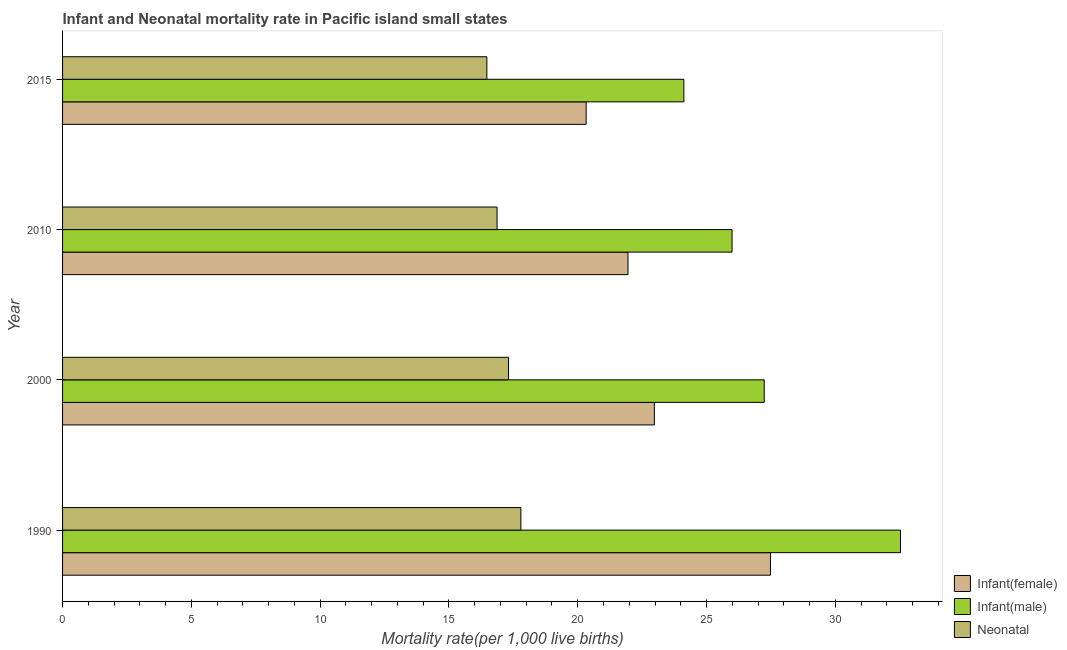How many groups of bars are there?
Provide a succinct answer. 4. How many bars are there on the 1st tick from the top?
Ensure brevity in your answer.  3. How many bars are there on the 3rd tick from the bottom?
Make the answer very short. 3. What is the label of the 2nd group of bars from the top?
Keep it short and to the point. 2010. What is the infant mortality rate(male) in 2015?
Your answer should be very brief. 24.12. Across all years, what is the maximum neonatal mortality rate?
Provide a succinct answer. 17.79. Across all years, what is the minimum infant mortality rate(male)?
Make the answer very short. 24.12. In which year was the infant mortality rate(male) minimum?
Your response must be concise. 2015. What is the total neonatal mortality rate in the graph?
Your answer should be very brief. 68.45. What is the difference between the neonatal mortality rate in 2010 and that in 2015?
Ensure brevity in your answer.  0.4. What is the difference between the infant mortality rate(female) in 1990 and the neonatal mortality rate in 2010?
Keep it short and to the point. 10.61. What is the average infant mortality rate(male) per year?
Provide a short and direct response. 27.47. In the year 1990, what is the difference between the neonatal mortality rate and infant mortality rate(male)?
Your answer should be very brief. -14.74. Is the neonatal mortality rate in 1990 less than that in 2000?
Your response must be concise. No. What is the difference between the highest and the second highest neonatal mortality rate?
Make the answer very short. 0.48. What is the difference between the highest and the lowest infant mortality rate(female)?
Make the answer very short. 7.16. What does the 2nd bar from the top in 1990 represents?
Provide a succinct answer. Infant(male). What does the 2nd bar from the bottom in 2010 represents?
Provide a short and direct response. Infant(male). How many bars are there?
Your response must be concise. 12. How many years are there in the graph?
Offer a terse response. 4. What is the difference between two consecutive major ticks on the X-axis?
Provide a succinct answer. 5. Are the values on the major ticks of X-axis written in scientific E-notation?
Ensure brevity in your answer.  No. How many legend labels are there?
Provide a succinct answer. 3. What is the title of the graph?
Give a very brief answer. Infant and Neonatal mortality rate in Pacific island small states. Does "Domestic" appear as one of the legend labels in the graph?
Keep it short and to the point. No. What is the label or title of the X-axis?
Offer a very short reply. Mortality rate(per 1,0 live births). What is the Mortality rate(per 1,000 live births) in Infant(female) in 1990?
Give a very brief answer. 27.48. What is the Mortality rate(per 1,000 live births) of Infant(male) in 1990?
Offer a very short reply. 32.53. What is the Mortality rate(per 1,000 live births) in Neonatal  in 1990?
Make the answer very short. 17.79. What is the Mortality rate(per 1,000 live births) in Infant(female) in 2000?
Offer a terse response. 22.97. What is the Mortality rate(per 1,000 live births) of Infant(male) in 2000?
Your answer should be compact. 27.24. What is the Mortality rate(per 1,000 live births) of Neonatal  in 2000?
Keep it short and to the point. 17.31. What is the Mortality rate(per 1,000 live births) in Infant(female) in 2010?
Your response must be concise. 21.95. What is the Mortality rate(per 1,000 live births) of Infant(male) in 2010?
Offer a very short reply. 25.99. What is the Mortality rate(per 1,000 live births) of Neonatal  in 2010?
Give a very brief answer. 16.87. What is the Mortality rate(per 1,000 live births) in Infant(female) in 2015?
Keep it short and to the point. 20.33. What is the Mortality rate(per 1,000 live births) in Infant(male) in 2015?
Give a very brief answer. 24.12. What is the Mortality rate(per 1,000 live births) in Neonatal  in 2015?
Ensure brevity in your answer.  16.47. Across all years, what is the maximum Mortality rate(per 1,000 live births) in Infant(female)?
Ensure brevity in your answer.  27.48. Across all years, what is the maximum Mortality rate(per 1,000 live births) of Infant(male)?
Give a very brief answer. 32.53. Across all years, what is the maximum Mortality rate(per 1,000 live births) of Neonatal ?
Your answer should be very brief. 17.79. Across all years, what is the minimum Mortality rate(per 1,000 live births) in Infant(female)?
Make the answer very short. 20.33. Across all years, what is the minimum Mortality rate(per 1,000 live births) of Infant(male)?
Provide a short and direct response. 24.12. Across all years, what is the minimum Mortality rate(per 1,000 live births) of Neonatal ?
Provide a succinct answer. 16.47. What is the total Mortality rate(per 1,000 live births) of Infant(female) in the graph?
Your answer should be compact. 92.73. What is the total Mortality rate(per 1,000 live births) of Infant(male) in the graph?
Give a very brief answer. 109.88. What is the total Mortality rate(per 1,000 live births) in Neonatal  in the graph?
Make the answer very short. 68.45. What is the difference between the Mortality rate(per 1,000 live births) in Infant(female) in 1990 and that in 2000?
Offer a very short reply. 4.51. What is the difference between the Mortality rate(per 1,000 live births) of Infant(male) in 1990 and that in 2000?
Provide a short and direct response. 5.29. What is the difference between the Mortality rate(per 1,000 live births) in Neonatal  in 1990 and that in 2000?
Your response must be concise. 0.48. What is the difference between the Mortality rate(per 1,000 live births) of Infant(female) in 1990 and that in 2010?
Your answer should be compact. 5.53. What is the difference between the Mortality rate(per 1,000 live births) of Infant(male) in 1990 and that in 2010?
Give a very brief answer. 6.54. What is the difference between the Mortality rate(per 1,000 live births) of Neonatal  in 1990 and that in 2010?
Provide a short and direct response. 0.92. What is the difference between the Mortality rate(per 1,000 live births) of Infant(female) in 1990 and that in 2015?
Your answer should be compact. 7.16. What is the difference between the Mortality rate(per 1,000 live births) in Infant(male) in 1990 and that in 2015?
Provide a succinct answer. 8.41. What is the difference between the Mortality rate(per 1,000 live births) of Neonatal  in 1990 and that in 2015?
Offer a very short reply. 1.32. What is the difference between the Mortality rate(per 1,000 live births) of Infant(female) in 2000 and that in 2010?
Provide a short and direct response. 1.02. What is the difference between the Mortality rate(per 1,000 live births) in Infant(male) in 2000 and that in 2010?
Provide a short and direct response. 1.25. What is the difference between the Mortality rate(per 1,000 live births) of Neonatal  in 2000 and that in 2010?
Your answer should be very brief. 0.45. What is the difference between the Mortality rate(per 1,000 live births) of Infant(female) in 2000 and that in 2015?
Your answer should be very brief. 2.65. What is the difference between the Mortality rate(per 1,000 live births) in Infant(male) in 2000 and that in 2015?
Your response must be concise. 3.12. What is the difference between the Mortality rate(per 1,000 live births) in Neonatal  in 2000 and that in 2015?
Give a very brief answer. 0.84. What is the difference between the Mortality rate(per 1,000 live births) of Infant(female) in 2010 and that in 2015?
Make the answer very short. 1.62. What is the difference between the Mortality rate(per 1,000 live births) of Infant(male) in 2010 and that in 2015?
Ensure brevity in your answer.  1.87. What is the difference between the Mortality rate(per 1,000 live births) in Neonatal  in 2010 and that in 2015?
Provide a succinct answer. 0.4. What is the difference between the Mortality rate(per 1,000 live births) in Infant(female) in 1990 and the Mortality rate(per 1,000 live births) in Infant(male) in 2000?
Give a very brief answer. 0.24. What is the difference between the Mortality rate(per 1,000 live births) of Infant(female) in 1990 and the Mortality rate(per 1,000 live births) of Neonatal  in 2000?
Your answer should be very brief. 10.17. What is the difference between the Mortality rate(per 1,000 live births) in Infant(male) in 1990 and the Mortality rate(per 1,000 live births) in Neonatal  in 2000?
Ensure brevity in your answer.  15.22. What is the difference between the Mortality rate(per 1,000 live births) of Infant(female) in 1990 and the Mortality rate(per 1,000 live births) of Infant(male) in 2010?
Offer a very short reply. 1.49. What is the difference between the Mortality rate(per 1,000 live births) in Infant(female) in 1990 and the Mortality rate(per 1,000 live births) in Neonatal  in 2010?
Make the answer very short. 10.61. What is the difference between the Mortality rate(per 1,000 live births) of Infant(male) in 1990 and the Mortality rate(per 1,000 live births) of Neonatal  in 2010?
Offer a very short reply. 15.66. What is the difference between the Mortality rate(per 1,000 live births) of Infant(female) in 1990 and the Mortality rate(per 1,000 live births) of Infant(male) in 2015?
Your answer should be very brief. 3.36. What is the difference between the Mortality rate(per 1,000 live births) of Infant(female) in 1990 and the Mortality rate(per 1,000 live births) of Neonatal  in 2015?
Make the answer very short. 11.01. What is the difference between the Mortality rate(per 1,000 live births) of Infant(male) in 1990 and the Mortality rate(per 1,000 live births) of Neonatal  in 2015?
Offer a terse response. 16.06. What is the difference between the Mortality rate(per 1,000 live births) of Infant(female) in 2000 and the Mortality rate(per 1,000 live births) of Infant(male) in 2010?
Your answer should be very brief. -3.02. What is the difference between the Mortality rate(per 1,000 live births) in Infant(female) in 2000 and the Mortality rate(per 1,000 live births) in Neonatal  in 2010?
Make the answer very short. 6.11. What is the difference between the Mortality rate(per 1,000 live births) in Infant(male) in 2000 and the Mortality rate(per 1,000 live births) in Neonatal  in 2010?
Ensure brevity in your answer.  10.37. What is the difference between the Mortality rate(per 1,000 live births) in Infant(female) in 2000 and the Mortality rate(per 1,000 live births) in Infant(male) in 2015?
Keep it short and to the point. -1.15. What is the difference between the Mortality rate(per 1,000 live births) in Infant(female) in 2000 and the Mortality rate(per 1,000 live births) in Neonatal  in 2015?
Give a very brief answer. 6.5. What is the difference between the Mortality rate(per 1,000 live births) of Infant(male) in 2000 and the Mortality rate(per 1,000 live births) of Neonatal  in 2015?
Keep it short and to the point. 10.77. What is the difference between the Mortality rate(per 1,000 live births) of Infant(female) in 2010 and the Mortality rate(per 1,000 live births) of Infant(male) in 2015?
Provide a succinct answer. -2.17. What is the difference between the Mortality rate(per 1,000 live births) in Infant(female) in 2010 and the Mortality rate(per 1,000 live births) in Neonatal  in 2015?
Your response must be concise. 5.48. What is the difference between the Mortality rate(per 1,000 live births) of Infant(male) in 2010 and the Mortality rate(per 1,000 live births) of Neonatal  in 2015?
Your response must be concise. 9.52. What is the average Mortality rate(per 1,000 live births) in Infant(female) per year?
Make the answer very short. 23.18. What is the average Mortality rate(per 1,000 live births) of Infant(male) per year?
Make the answer very short. 27.47. What is the average Mortality rate(per 1,000 live births) in Neonatal  per year?
Your answer should be very brief. 17.11. In the year 1990, what is the difference between the Mortality rate(per 1,000 live births) of Infant(female) and Mortality rate(per 1,000 live births) of Infant(male)?
Ensure brevity in your answer.  -5.05. In the year 1990, what is the difference between the Mortality rate(per 1,000 live births) in Infant(female) and Mortality rate(per 1,000 live births) in Neonatal ?
Offer a very short reply. 9.69. In the year 1990, what is the difference between the Mortality rate(per 1,000 live births) in Infant(male) and Mortality rate(per 1,000 live births) in Neonatal ?
Keep it short and to the point. 14.74. In the year 2000, what is the difference between the Mortality rate(per 1,000 live births) of Infant(female) and Mortality rate(per 1,000 live births) of Infant(male)?
Provide a short and direct response. -4.27. In the year 2000, what is the difference between the Mortality rate(per 1,000 live births) in Infant(female) and Mortality rate(per 1,000 live births) in Neonatal ?
Make the answer very short. 5.66. In the year 2000, what is the difference between the Mortality rate(per 1,000 live births) of Infant(male) and Mortality rate(per 1,000 live births) of Neonatal ?
Offer a terse response. 9.93. In the year 2010, what is the difference between the Mortality rate(per 1,000 live births) of Infant(female) and Mortality rate(per 1,000 live births) of Infant(male)?
Offer a very short reply. -4.04. In the year 2010, what is the difference between the Mortality rate(per 1,000 live births) in Infant(female) and Mortality rate(per 1,000 live births) in Neonatal ?
Ensure brevity in your answer.  5.08. In the year 2010, what is the difference between the Mortality rate(per 1,000 live births) in Infant(male) and Mortality rate(per 1,000 live births) in Neonatal ?
Make the answer very short. 9.12. In the year 2015, what is the difference between the Mortality rate(per 1,000 live births) of Infant(female) and Mortality rate(per 1,000 live births) of Infant(male)?
Give a very brief answer. -3.79. In the year 2015, what is the difference between the Mortality rate(per 1,000 live births) in Infant(female) and Mortality rate(per 1,000 live births) in Neonatal ?
Your answer should be very brief. 3.85. In the year 2015, what is the difference between the Mortality rate(per 1,000 live births) in Infant(male) and Mortality rate(per 1,000 live births) in Neonatal ?
Your response must be concise. 7.65. What is the ratio of the Mortality rate(per 1,000 live births) in Infant(female) in 1990 to that in 2000?
Make the answer very short. 1.2. What is the ratio of the Mortality rate(per 1,000 live births) of Infant(male) in 1990 to that in 2000?
Provide a succinct answer. 1.19. What is the ratio of the Mortality rate(per 1,000 live births) in Neonatal  in 1990 to that in 2000?
Make the answer very short. 1.03. What is the ratio of the Mortality rate(per 1,000 live births) of Infant(female) in 1990 to that in 2010?
Offer a very short reply. 1.25. What is the ratio of the Mortality rate(per 1,000 live births) in Infant(male) in 1990 to that in 2010?
Provide a succinct answer. 1.25. What is the ratio of the Mortality rate(per 1,000 live births) of Neonatal  in 1990 to that in 2010?
Make the answer very short. 1.05. What is the ratio of the Mortality rate(per 1,000 live births) in Infant(female) in 1990 to that in 2015?
Make the answer very short. 1.35. What is the ratio of the Mortality rate(per 1,000 live births) in Infant(male) in 1990 to that in 2015?
Your answer should be compact. 1.35. What is the ratio of the Mortality rate(per 1,000 live births) in Neonatal  in 1990 to that in 2015?
Keep it short and to the point. 1.08. What is the ratio of the Mortality rate(per 1,000 live births) in Infant(female) in 2000 to that in 2010?
Your answer should be very brief. 1.05. What is the ratio of the Mortality rate(per 1,000 live births) of Infant(male) in 2000 to that in 2010?
Your response must be concise. 1.05. What is the ratio of the Mortality rate(per 1,000 live births) of Neonatal  in 2000 to that in 2010?
Make the answer very short. 1.03. What is the ratio of the Mortality rate(per 1,000 live births) in Infant(female) in 2000 to that in 2015?
Offer a terse response. 1.13. What is the ratio of the Mortality rate(per 1,000 live births) of Infant(male) in 2000 to that in 2015?
Ensure brevity in your answer.  1.13. What is the ratio of the Mortality rate(per 1,000 live births) in Neonatal  in 2000 to that in 2015?
Your response must be concise. 1.05. What is the ratio of the Mortality rate(per 1,000 live births) in Infant(female) in 2010 to that in 2015?
Keep it short and to the point. 1.08. What is the ratio of the Mortality rate(per 1,000 live births) in Infant(male) in 2010 to that in 2015?
Your answer should be very brief. 1.08. What is the difference between the highest and the second highest Mortality rate(per 1,000 live births) of Infant(female)?
Your answer should be compact. 4.51. What is the difference between the highest and the second highest Mortality rate(per 1,000 live births) of Infant(male)?
Offer a very short reply. 5.29. What is the difference between the highest and the second highest Mortality rate(per 1,000 live births) of Neonatal ?
Offer a terse response. 0.48. What is the difference between the highest and the lowest Mortality rate(per 1,000 live births) in Infant(female)?
Keep it short and to the point. 7.16. What is the difference between the highest and the lowest Mortality rate(per 1,000 live births) in Infant(male)?
Your response must be concise. 8.41. What is the difference between the highest and the lowest Mortality rate(per 1,000 live births) in Neonatal ?
Your response must be concise. 1.32. 